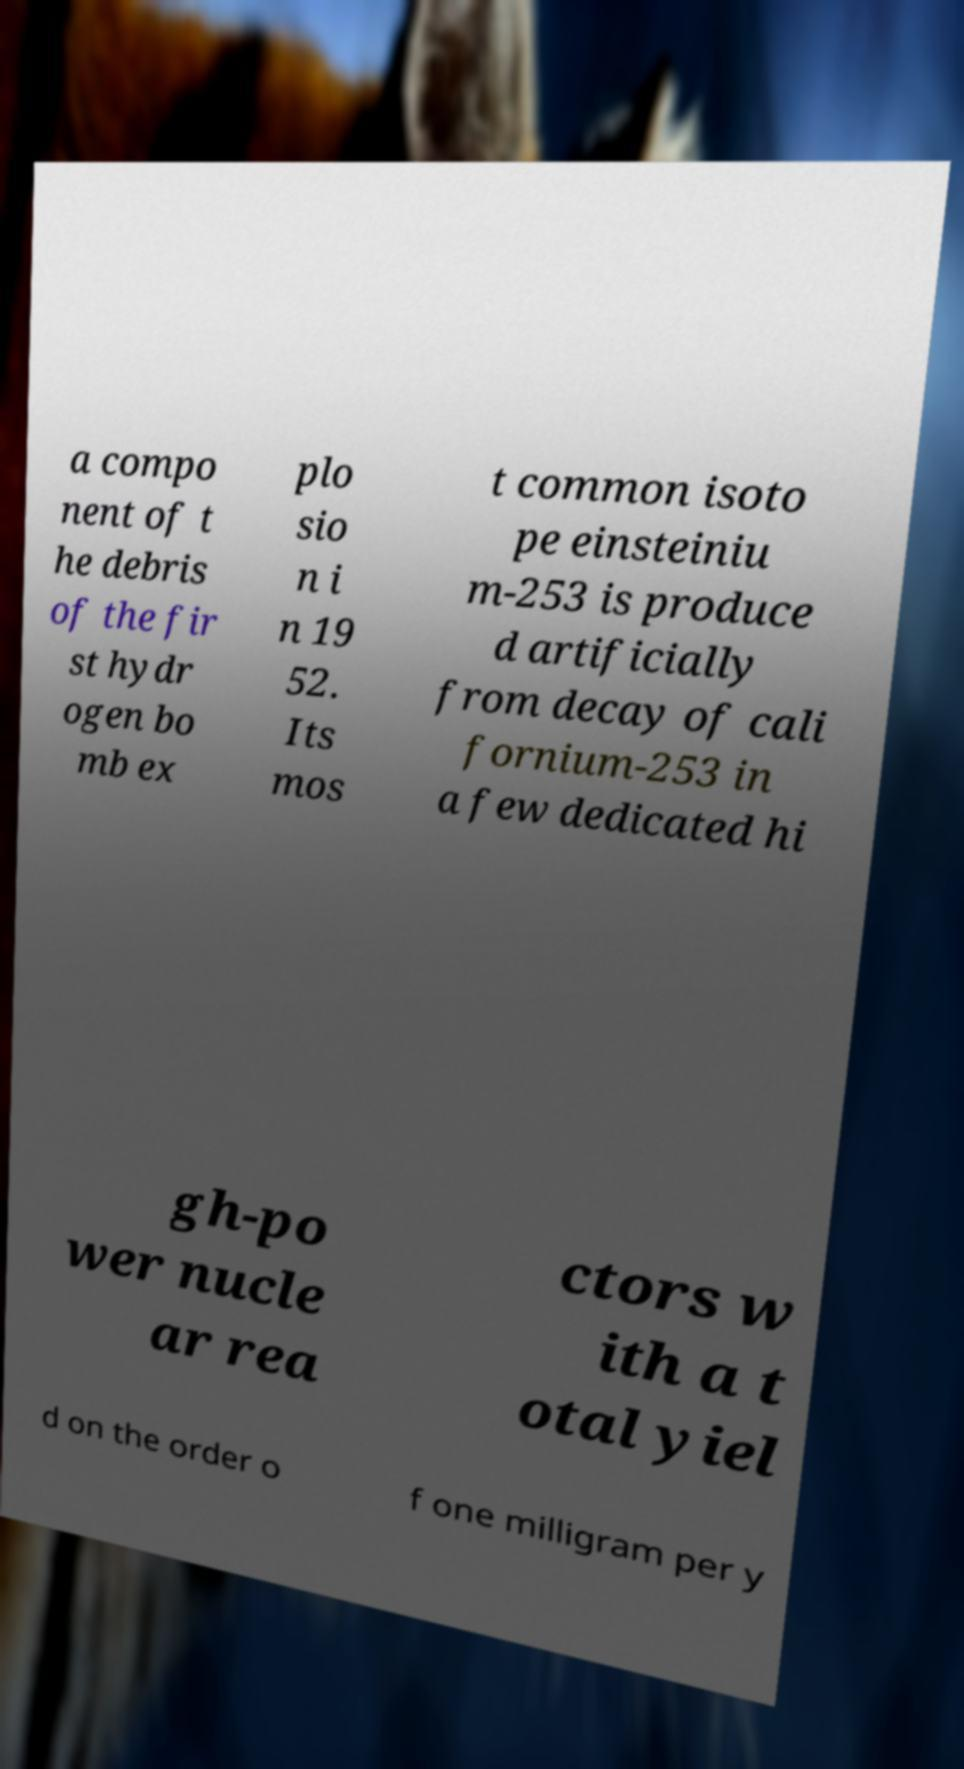Can you read and provide the text displayed in the image?This photo seems to have some interesting text. Can you extract and type it out for me? a compo nent of t he debris of the fir st hydr ogen bo mb ex plo sio n i n 19 52. Its mos t common isoto pe einsteiniu m-253 is produce d artificially from decay of cali fornium-253 in a few dedicated hi gh-po wer nucle ar rea ctors w ith a t otal yiel d on the order o f one milligram per y 